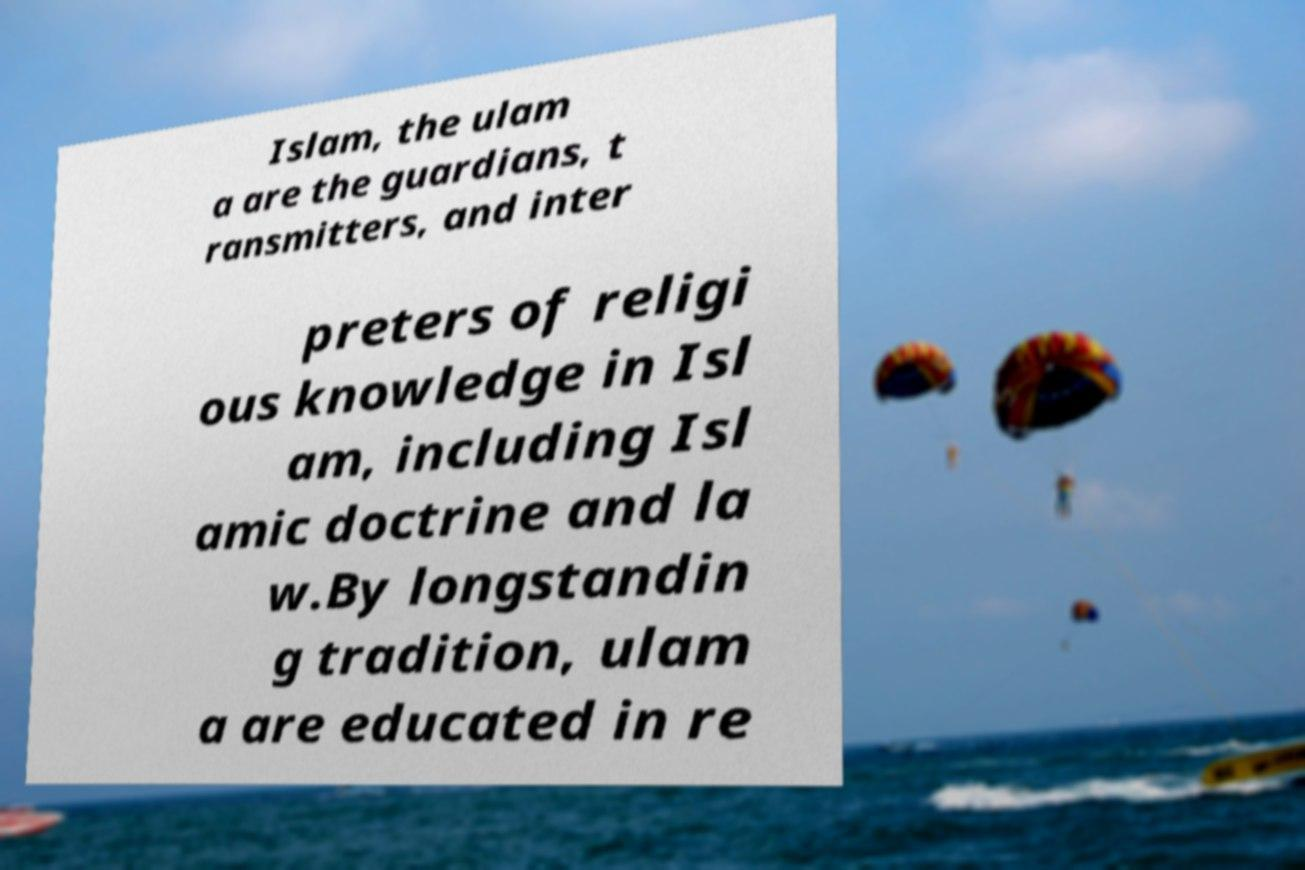Can you accurately transcribe the text from the provided image for me? Islam, the ulam a are the guardians, t ransmitters, and inter preters of religi ous knowledge in Isl am, including Isl amic doctrine and la w.By longstandin g tradition, ulam a are educated in re 